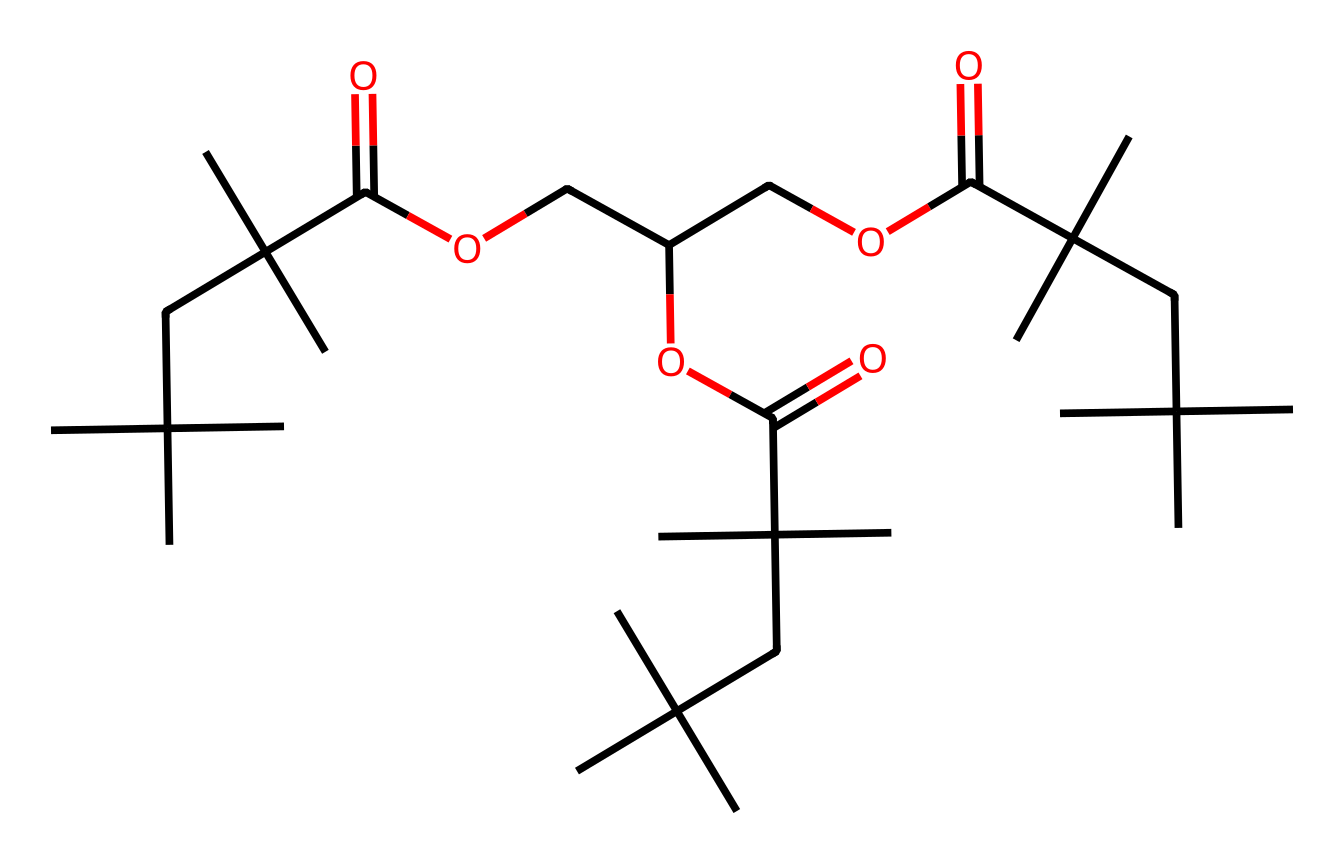What is the primary functional group present in this chemical? The chemical contains a carboxylic acid functional group indicated by the -COOH portion of the structure. The presence of a carbonyl (C=O) and a hydroxyl (OH) together identifies it as an acid.
Answer: carboxylic acid How many carbon atoms are in the chemical structure? By analyzing the SMILES representation, we can count the number of 'C' symbols in the chemical. The total number of carbon atoms adds up to 30, based on what is shown in the structure.
Answer: 30 What type of lubricant is this chemical likely to be? Given the components such as esters and the presence of anti-corrosion properties, this chemical is formulated as a functional lubricant designed for protection against rust and corrosion in saltwater environments.
Answer: anti-corrosion lubricant What characteristic might this chemical provide against saltwater corrosion? The presence of ester linkages within the chemical structure allows for hydrophobic interactions and thus water resistance, which is crucial for reducing corrosion in exposure to saltwater.
Answer: water resistance Does this structure contain any esters? Yes, the presence of -O- (oxygen atoms between carbon chains) indicates that this chemical contains esters, which are typically present in lubricants for their slippery properties.
Answer: yes 